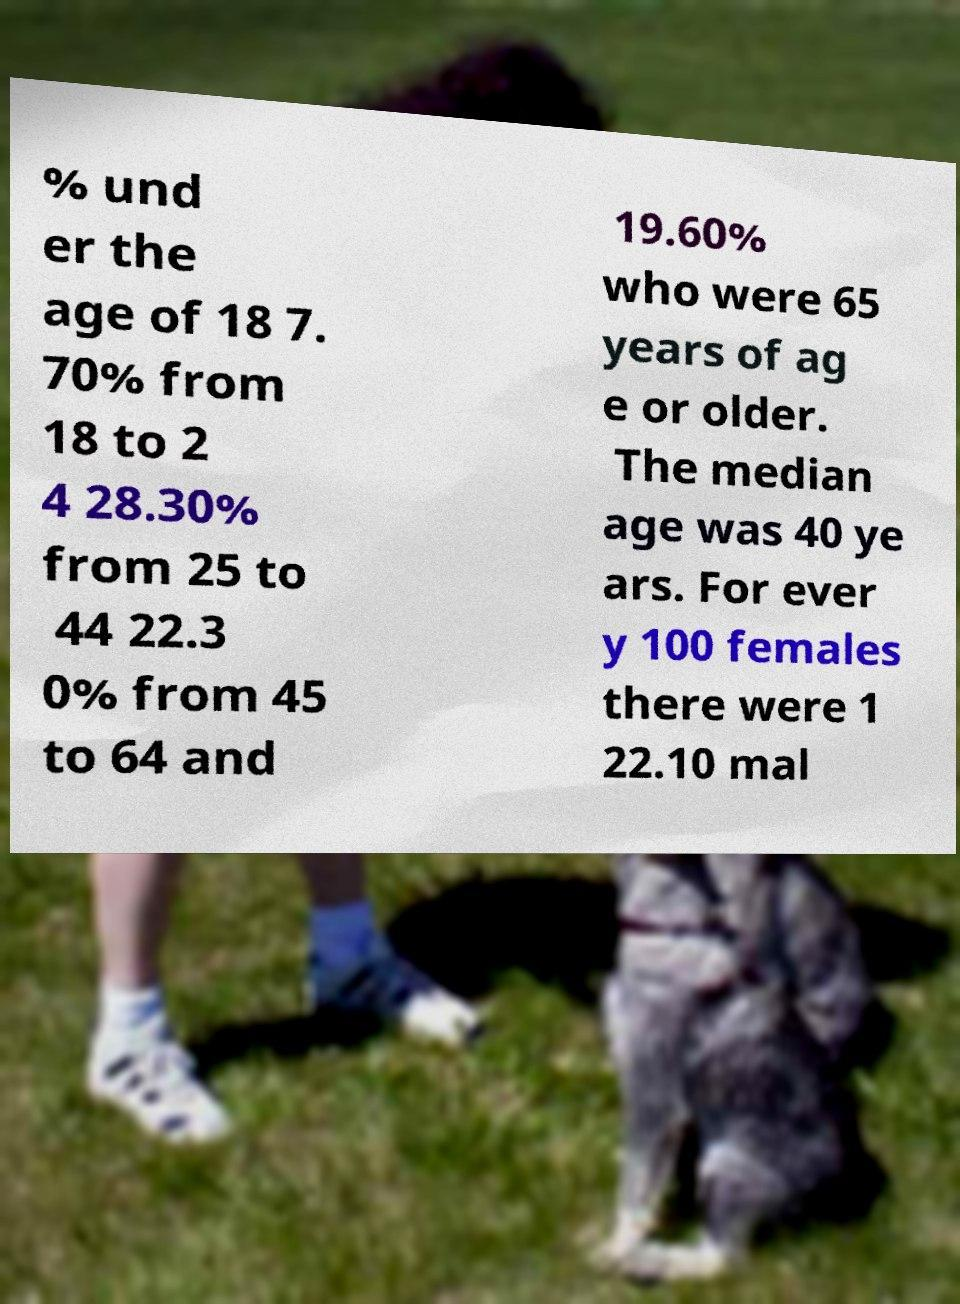Please identify and transcribe the text found in this image. % und er the age of 18 7. 70% from 18 to 2 4 28.30% from 25 to 44 22.3 0% from 45 to 64 and 19.60% who were 65 years of ag e or older. The median age was 40 ye ars. For ever y 100 females there were 1 22.10 mal 